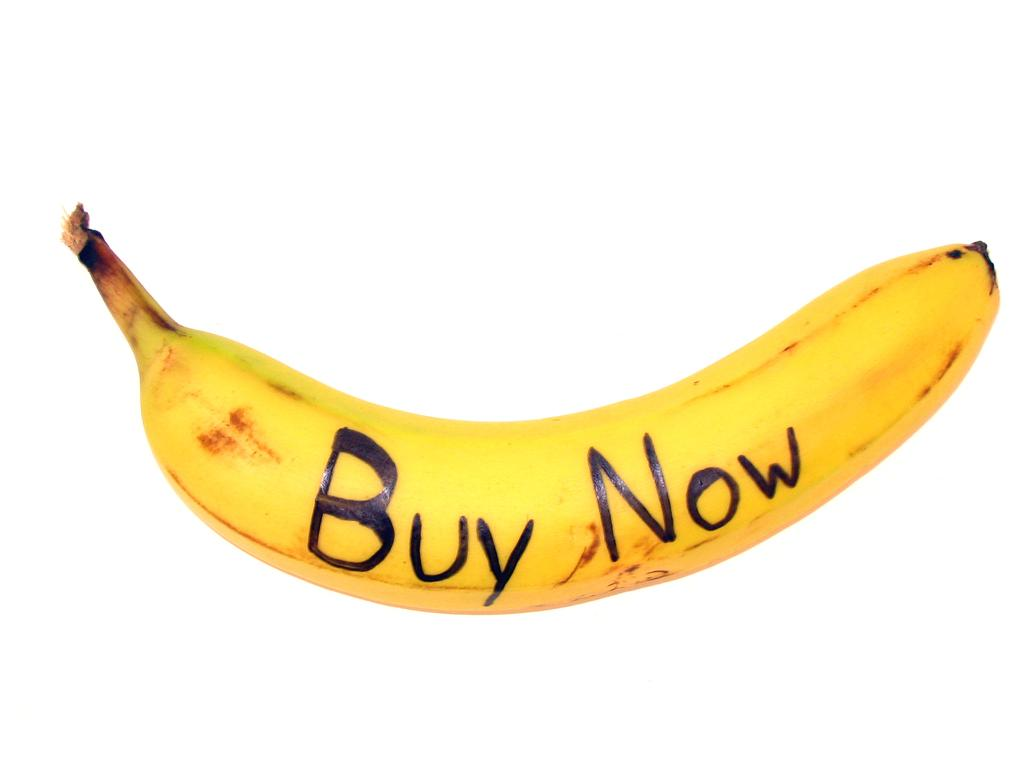What type of fruit is present in the image? There is a banana in the image. What color is the background of the image? The background of the image is white. What type of chess piece is depicted on the banana in the image? There is no chess piece or any other object depicted on the banana in the image. What songs can be heard playing in the background of the image? There is no audio or music present in the image, so it is not possible to determine what songs might be heard. 